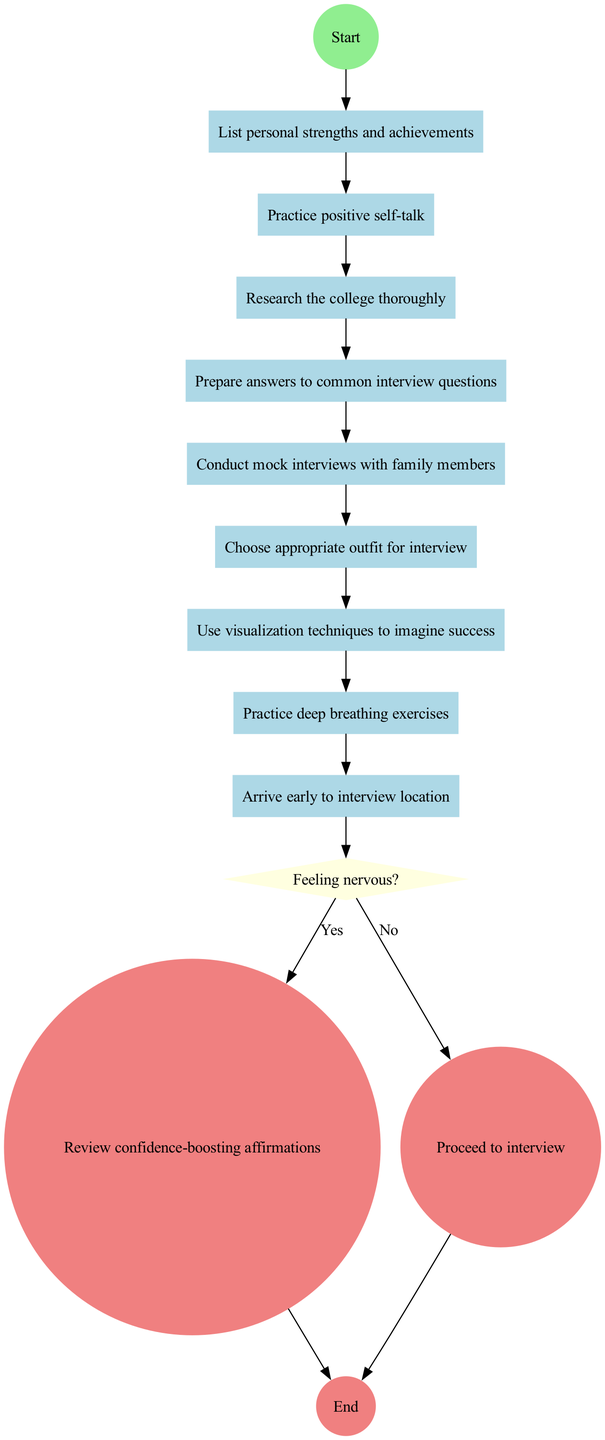What is the start node of the diagram? The start node, indicated as the first node in the flow of the diagram, is labeled "Read parenting blog post on confidence-building".
Answer: Read parenting blog post on confidence-building How many activities are listed in the diagram? Counting all activities from the activities section, there are a total of nine activities mentioned in the diagram.
Answer: 9 What follows after the last activity in the diagram? After the last activity, which is "Practice deep breathing exercises", the next node is a decision node asking, "Feeling nervous?".
Answer: Feeling nervous? If the answer to the decision node is "Yes", what node do you reach next? If "Yes" is selected in response to feeling nervous, the diagram leads to reviewing confidence-boosting affirmations, which is the next action in this scenario.
Answer: Review confidence-boosting affirmations What is the shape of the decision node in the diagram? The decision node, indicating a point where choices are made, is represented by a diamond shape in the diagram.
Answer: Diamond What happens if the answer to the decision node is "No"? If the answer is "No", the flow in the diagram leads directly to the next node, which is the end node labeled "Complete college interview".
Answer: Complete college interview How do you reach the end node from the start node? To reach the end node from the start node, you must progress through all activities in order, reach the decision node, and finally follow either the "Yes" or "No" path to the end node.
Answer: Through activities to decision node What is the final outcome indicated in the diagram? The final outcome presented in the diagram is labeled as "Complete college interview", marking the end of the flow.
Answer: Complete college interview What color is used for the activity nodes in the diagram? The activity nodes are colored light blue, which distinguishes them from other types of nodes in the diagram.
Answer: Light blue 